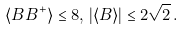<formula> <loc_0><loc_0><loc_500><loc_500>\langle B B ^ { + } \rangle \leq 8 , \, | \langle B \rangle | \leq 2 { \sqrt { 2 } } \, .</formula> 